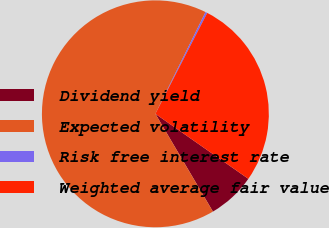Convert chart to OTSL. <chart><loc_0><loc_0><loc_500><loc_500><pie_chart><fcel>Dividend yield<fcel>Expected volatility<fcel>Risk free interest rate<fcel>Weighted average fair value<nl><fcel>6.82%<fcel>65.75%<fcel>0.27%<fcel>27.15%<nl></chart> 